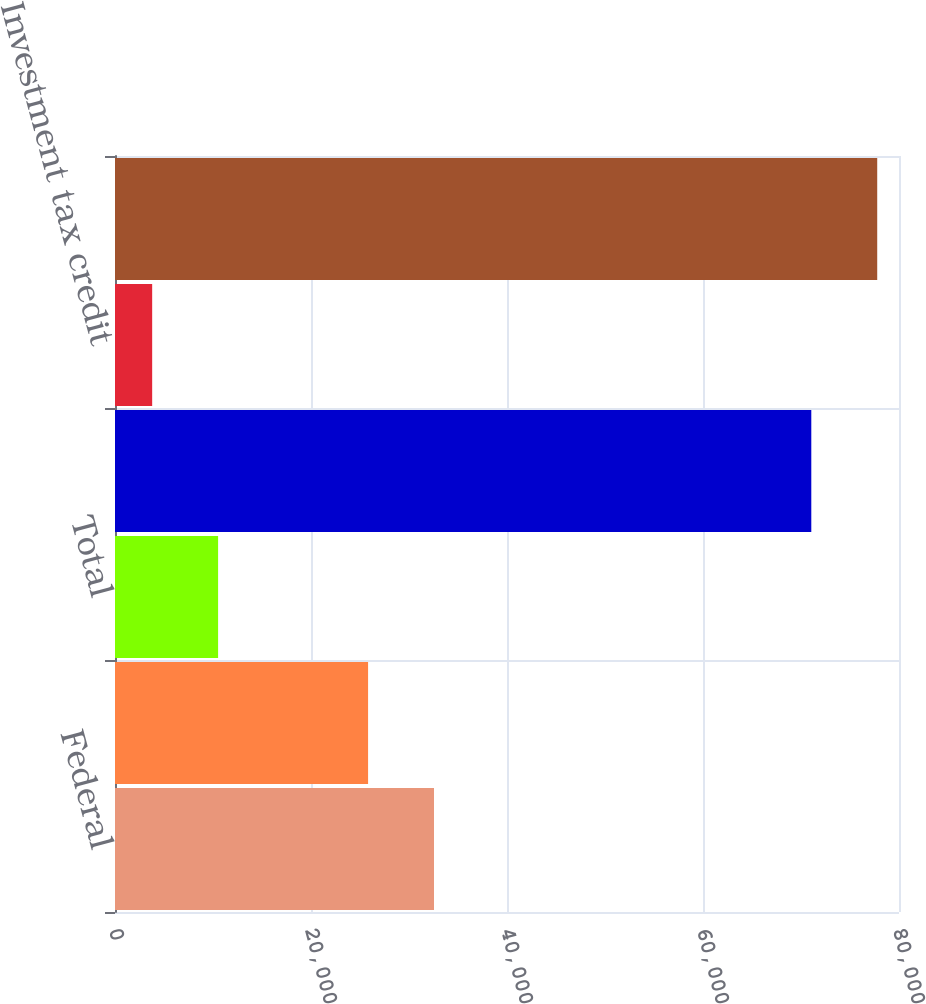Convert chart. <chart><loc_0><loc_0><loc_500><loc_500><bar_chart><fcel>Federal<fcel>State<fcel>Total<fcel>Deferred and non-current - net<fcel>Investment tax credit<fcel>Income taxes<nl><fcel>32551.8<fcel>25825<fcel>10519.8<fcel>71051<fcel>3793<fcel>77777.8<nl></chart> 